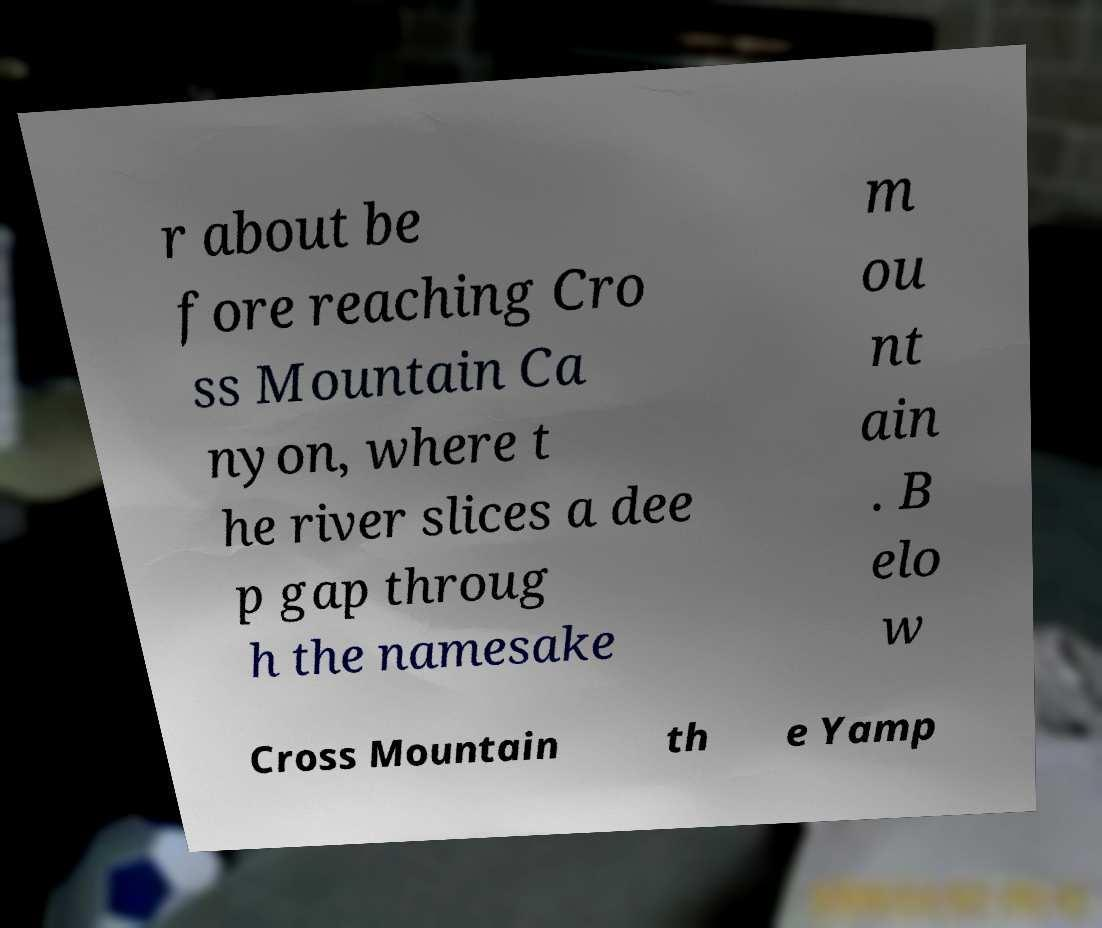Can you read and provide the text displayed in the image?This photo seems to have some interesting text. Can you extract and type it out for me? r about be fore reaching Cro ss Mountain Ca nyon, where t he river slices a dee p gap throug h the namesake m ou nt ain . B elo w Cross Mountain th e Yamp 